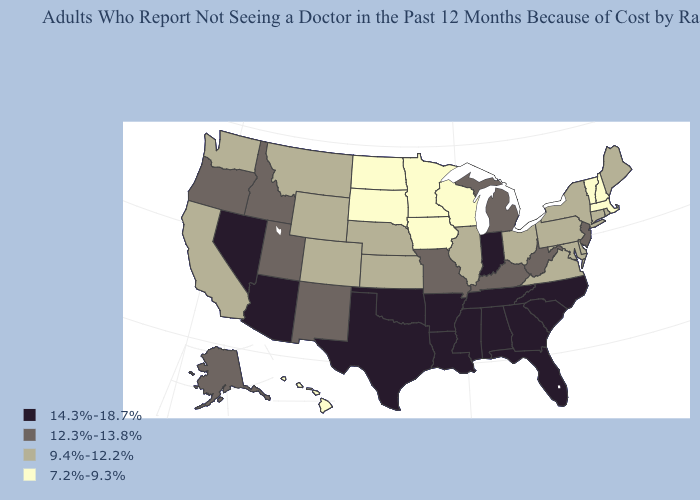Does Wisconsin have the lowest value in the MidWest?
Quick response, please. Yes. Name the states that have a value in the range 14.3%-18.7%?
Answer briefly. Alabama, Arizona, Arkansas, Florida, Georgia, Indiana, Louisiana, Mississippi, Nevada, North Carolina, Oklahoma, South Carolina, Tennessee, Texas. Name the states that have a value in the range 7.2%-9.3%?
Answer briefly. Hawaii, Iowa, Massachusetts, Minnesota, New Hampshire, North Dakota, South Dakota, Vermont, Wisconsin. Which states have the highest value in the USA?
Answer briefly. Alabama, Arizona, Arkansas, Florida, Georgia, Indiana, Louisiana, Mississippi, Nevada, North Carolina, Oklahoma, South Carolina, Tennessee, Texas. Among the states that border New Jersey , which have the highest value?
Be succinct. Delaware, New York, Pennsylvania. What is the value of Rhode Island?
Be succinct. 9.4%-12.2%. Which states have the highest value in the USA?
Short answer required. Alabama, Arizona, Arkansas, Florida, Georgia, Indiana, Louisiana, Mississippi, Nevada, North Carolina, Oklahoma, South Carolina, Tennessee, Texas. Does South Dakota have the highest value in the USA?
Be succinct. No. Among the states that border Montana , which have the highest value?
Answer briefly. Idaho. Among the states that border Arkansas , does Oklahoma have the highest value?
Be succinct. Yes. Does Texas have the highest value in the USA?
Give a very brief answer. Yes. Name the states that have a value in the range 14.3%-18.7%?
Short answer required. Alabama, Arizona, Arkansas, Florida, Georgia, Indiana, Louisiana, Mississippi, Nevada, North Carolina, Oklahoma, South Carolina, Tennessee, Texas. Which states have the highest value in the USA?
Short answer required. Alabama, Arizona, Arkansas, Florida, Georgia, Indiana, Louisiana, Mississippi, Nevada, North Carolina, Oklahoma, South Carolina, Tennessee, Texas. What is the highest value in the Northeast ?
Give a very brief answer. 12.3%-13.8%. Does Pennsylvania have a lower value than Iowa?
Keep it brief. No. 